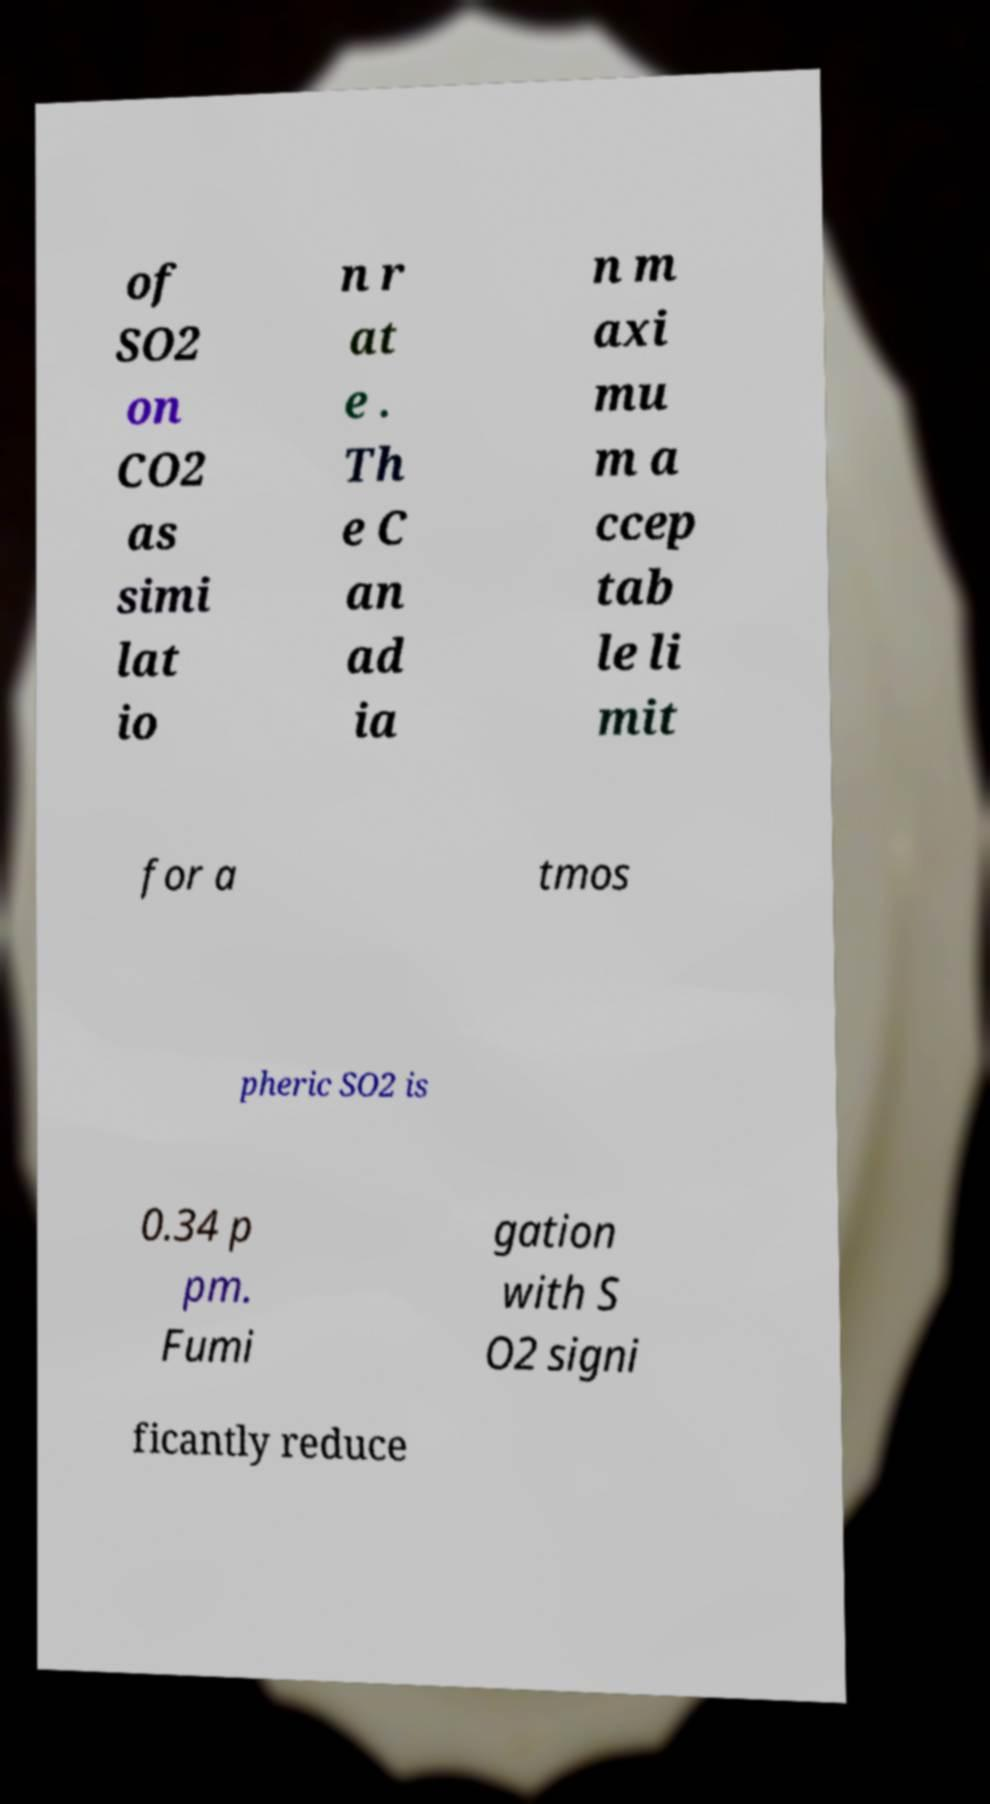What messages or text are displayed in this image? I need them in a readable, typed format. of SO2 on CO2 as simi lat io n r at e . Th e C an ad ia n m axi mu m a ccep tab le li mit for a tmos pheric SO2 is 0.34 p pm. Fumi gation with S O2 signi ficantly reduce 